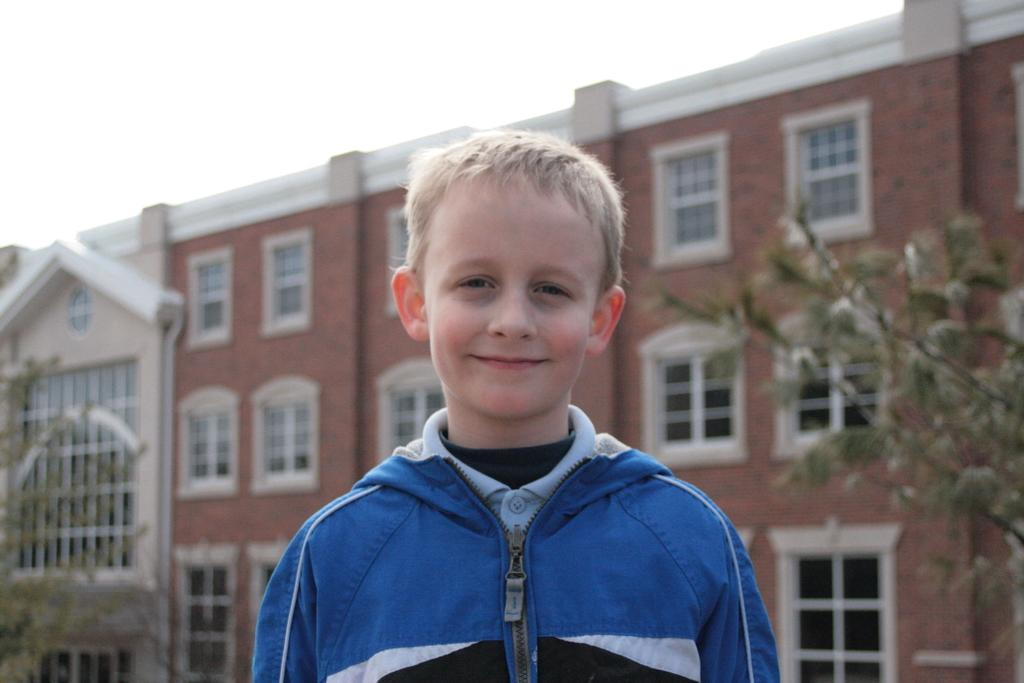Who is in the image? There is a boy in the image. What is the boy doing? The boy is smiling. What is the boy wearing? The boy is wearing a blue coat. What can be seen in the background of the image? There is a big building in the background of the image. What type of vegetation is present on either side of the image? There are trees on either side of the image. What is visible at the top of the image? The sky is visible at the top of the image. What hall is the boy walking through in the image? There is no hall present in the image; it is an outdoor scene with a boy, trees, a building, and the sky. 